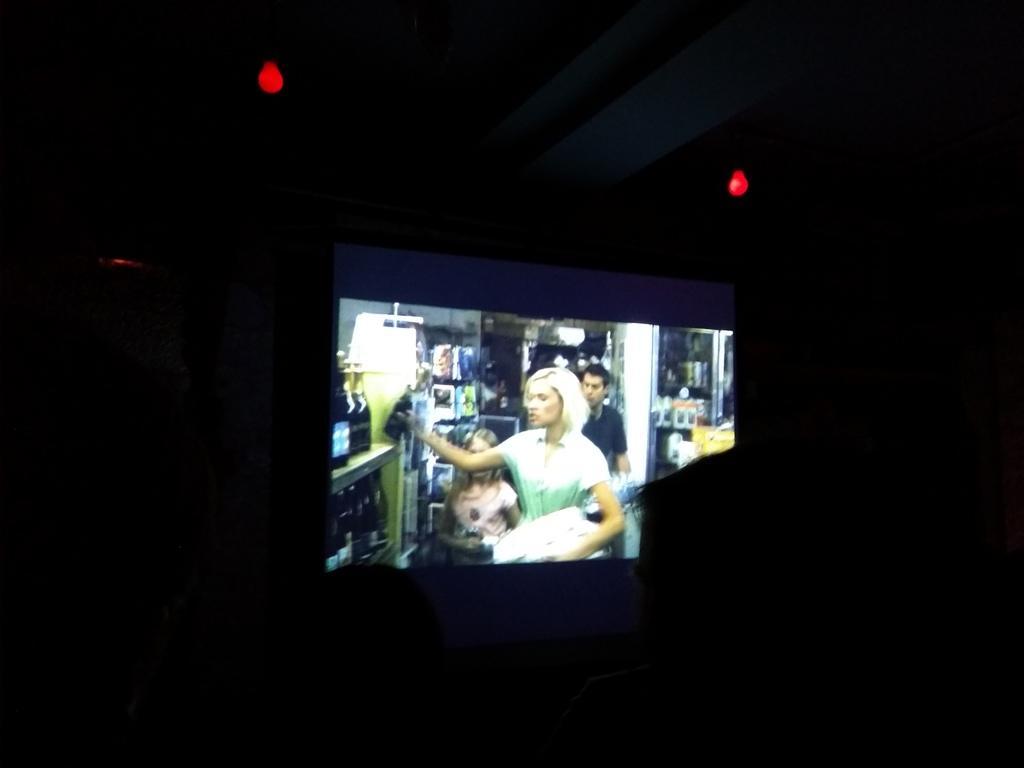Could you give a brief overview of what you see in this image? In this picture we can see a projector and two bulbs on top. We can see a wall. 